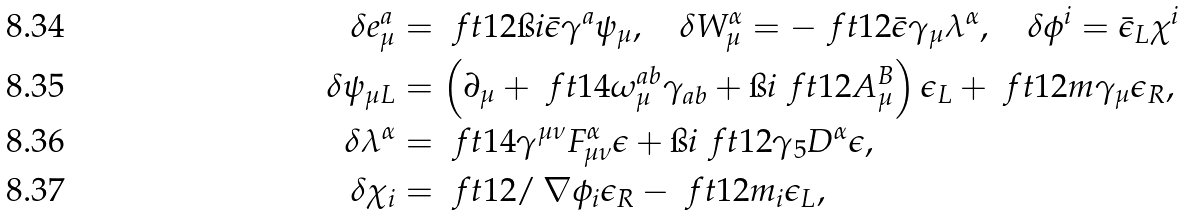<formula> <loc_0><loc_0><loc_500><loc_500>\delta e ^ { a } _ { \mu } & = \ f t 1 2 \i i \bar { \epsilon } \gamma ^ { a } \psi _ { \mu } , \quad \delta W ^ { \alpha } _ { \mu } = - \ f t 1 2 \bar { \epsilon } \gamma _ { \mu } \lambda ^ { \alpha } , \quad \delta \phi ^ { i } = \bar { \epsilon } _ { L } \chi ^ { i } \\ \delta \psi _ { \mu L } & = \left ( { \partial _ { \mu } + \ f t { 1 } { 4 } \omega _ { \mu } ^ { a b } \gamma _ { a b } + \i i \ f t { 1 } { 2 } A _ { \mu } ^ { B } } \right ) \epsilon _ { L } + \ f t 1 2 m \gamma _ { \mu } \epsilon _ { R } , \\ \delta \lambda ^ { \alpha } & = \ f t { 1 } { 4 } \gamma ^ { \mu \nu } F ^ { \alpha } _ { \mu \nu } \epsilon + \i i \ f t { 1 } { 2 } \gamma _ { 5 } D ^ { \alpha } \epsilon , \\ \delta \chi _ { i } & = \ f t { 1 } { 2 } \slash \, \nabla \phi _ { i } \epsilon _ { R } - \ f t { 1 } { 2 } m _ { i } \epsilon _ { L } ,</formula> 